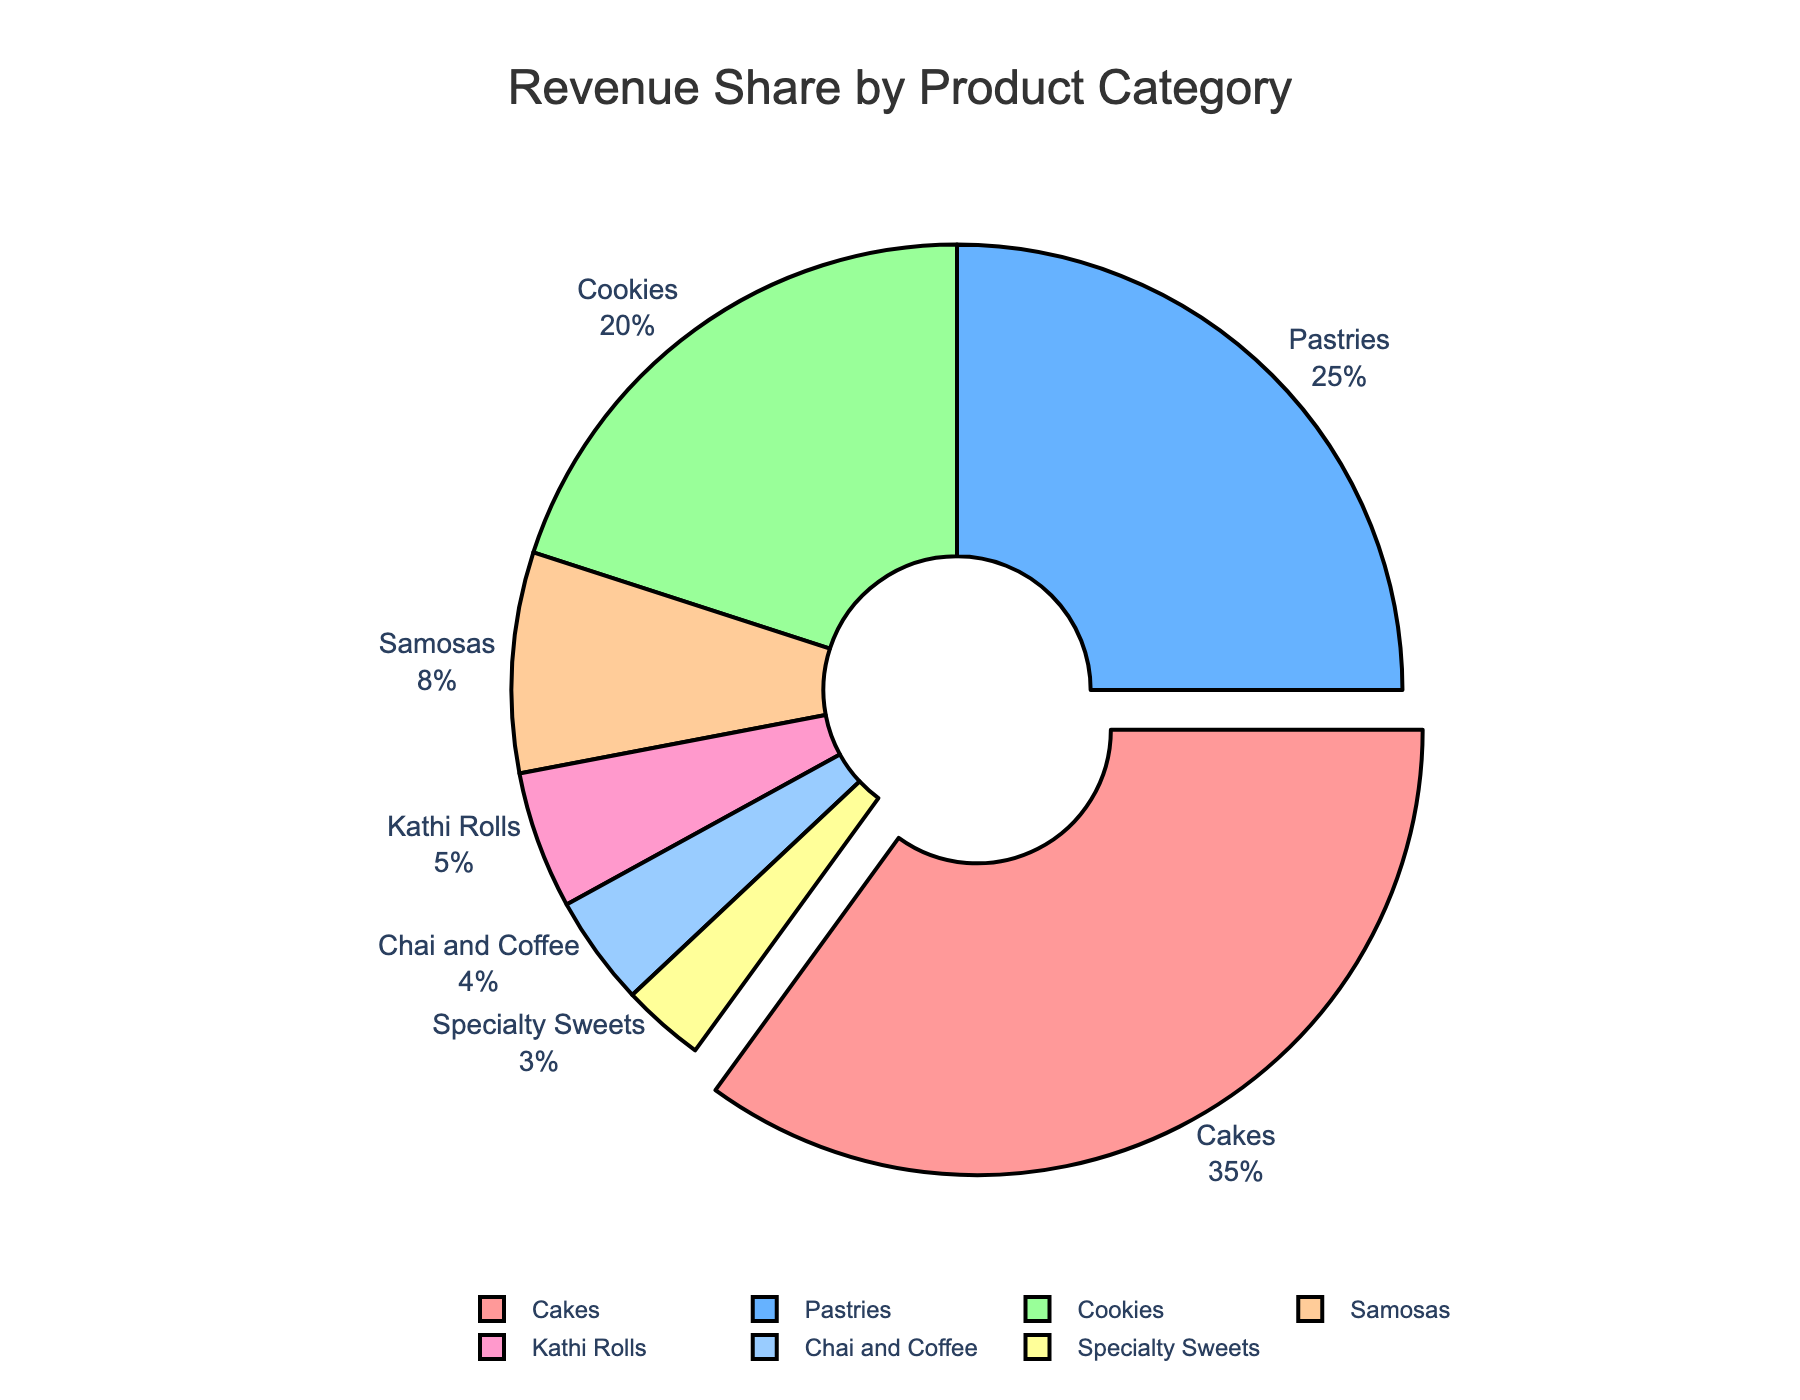Which product category has the largest revenue share? The product category with the largest revenue share will have the largest slice in the pie chart. In this case, it is "Cakes."
Answer: Cakes What percentage of the total revenue comes from pastries and cookies combined? To find the combined percentage of pastries and cookies, sum the percentages for each. Pastries contribute 25% and cookies contribute 20%, so the total is 25 + 20 = 45%.
Answer: 45% How much greater is the revenue share of cakes compared to cookies? To determine the difference, subtract the percentage of cookies from the percentage of cakes. Cakes have 35% and cookies have 20%, so the difference is 35 - 20 = 15%.
Answer: 15% Which product category has the smallest share of the revenue? The smallest share is indicated by the smallest slice in the pie chart. Here, it is "Specialty Sweets" with 3%.
Answer: Specialty Sweets If the revenue share for chai and coffee increased by 50%, what would the new percentage be? To calculate a 50% increase for chai and coffee, multiply the current share by 1.5. The current revenue share is 4%, so the new share would be 4 * 1.5 = 6%.
Answer: 6% How do the combined revenue shares of samosas and kathi rolls compare to the revenue share of cakes? Sum the percentages of samosas and kathi rolls and then compare to the revenue share of cakes. Samosas contribute 8% and kathi rolls contribute 5%, so combined, they are 8 + 5 = 13%, compared to cakes' 35%. 13% is less than 35%.
Answer: Less Which two categories together make up half of the total revenue? To determine which two categories make up half of the total revenue, sort the shares and sum the highest two until reaching approximately 50%. Cakes and pastries are the top two, contributing 35% and 25%, which sums to 60%, closer than any other pair to half of the total revenue.
Answer: Cakes and Pastries How many categories contribute less than 10% each to the total revenue? Examine each category and count how many have a revenue share of less than 10%. Samosas (8%), kathi rolls (5%), chai and coffee (4%), and specialty sweets (3%) meet this criterion. There are 4 such categories.
Answer: 4 What is the average revenue share of cookies, samosas, and kathi rolls? Calculate the average by summing the revenue shares of cookies, samosas, and kathi rolls and then dividing by 3. Cookies have 20%, samosas have 8%, and kathi rolls have 5%, summing to 33%. The average is 33 / 3 = 11%.
Answer: 11% Which category has a revenue share that is closer to the combined revenue share of chai and coffee plus specialty sweets? Sum the revenue shares of chai and coffee, and specialty sweets, then determine which category's share is closest to this sum. Chai and coffee is 4% and specialty sweets is 3%, summing to 4 + 3 = 7%. Kathi rolls at 5% is the closest to 7%.
Answer: Kathi Rolls 